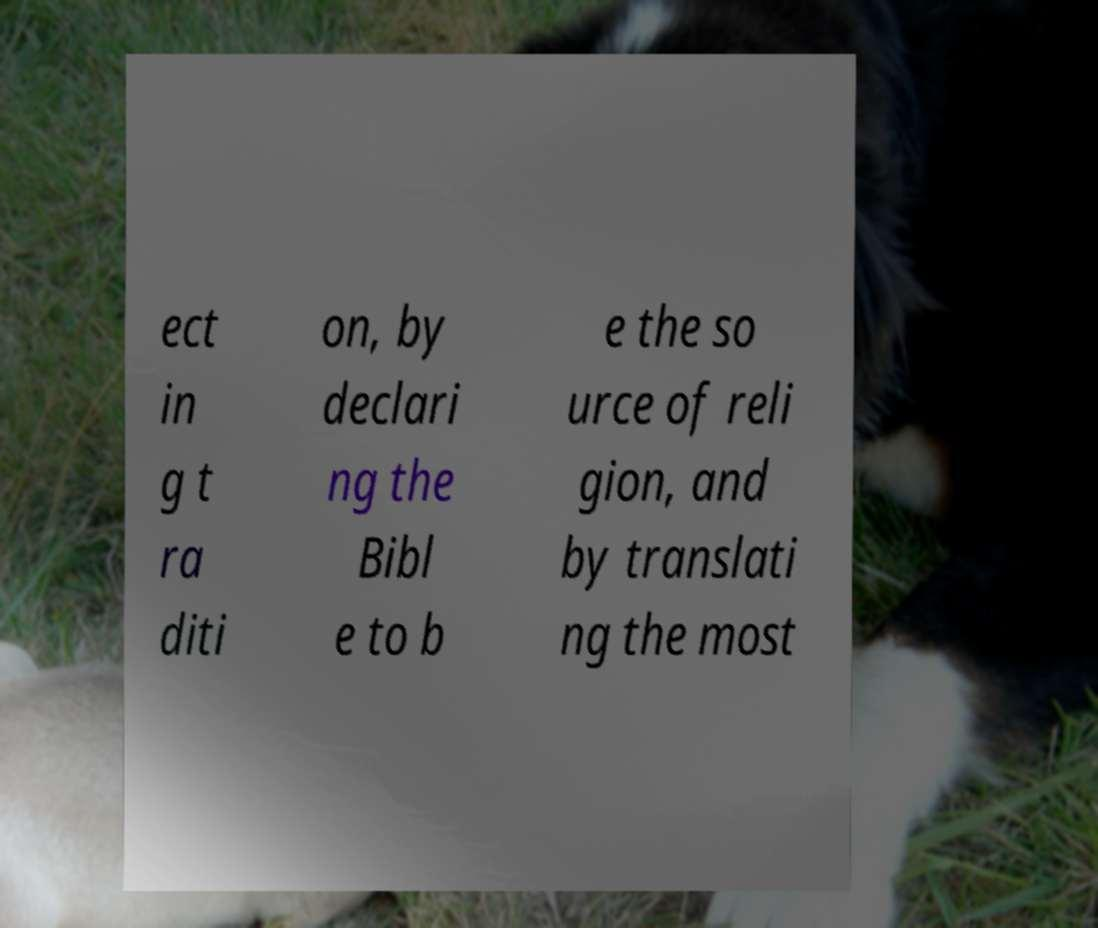For documentation purposes, I need the text within this image transcribed. Could you provide that? ect in g t ra diti on, by declari ng the Bibl e to b e the so urce of reli gion, and by translati ng the most 